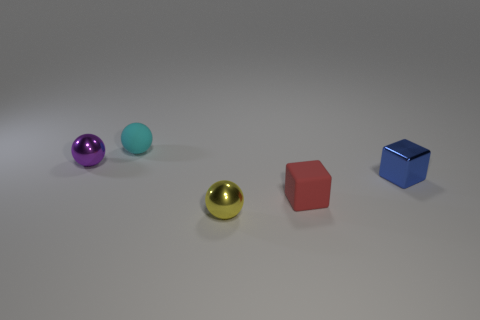What material is the blue thing that is the same shape as the red thing?
Give a very brief answer. Metal. Is there a yellow object that has the same material as the tiny blue object?
Your answer should be compact. Yes. Is there any other thing that has the same material as the yellow sphere?
Provide a short and direct response. Yes. The tiny object behind the tiny metal thing that is behind the blue metal block is made of what material?
Provide a succinct answer. Rubber. There is a metal sphere behind the tiny red rubber thing on the right side of the metal thing on the left side of the cyan sphere; how big is it?
Ensure brevity in your answer.  Small. What number of other objects are the same shape as the small red object?
Give a very brief answer. 1. There is a matte object on the right side of the small cyan rubber sphere; is its color the same as the metallic thing that is left of the tiny yellow thing?
Your answer should be compact. No. There is a metal cube that is the same size as the purple metallic thing; what is its color?
Your answer should be compact. Blue. Are there any small rubber things of the same color as the matte block?
Make the answer very short. No. There is a matte thing that is in front of the cyan rubber thing; does it have the same size as the yellow object?
Your answer should be compact. Yes. 